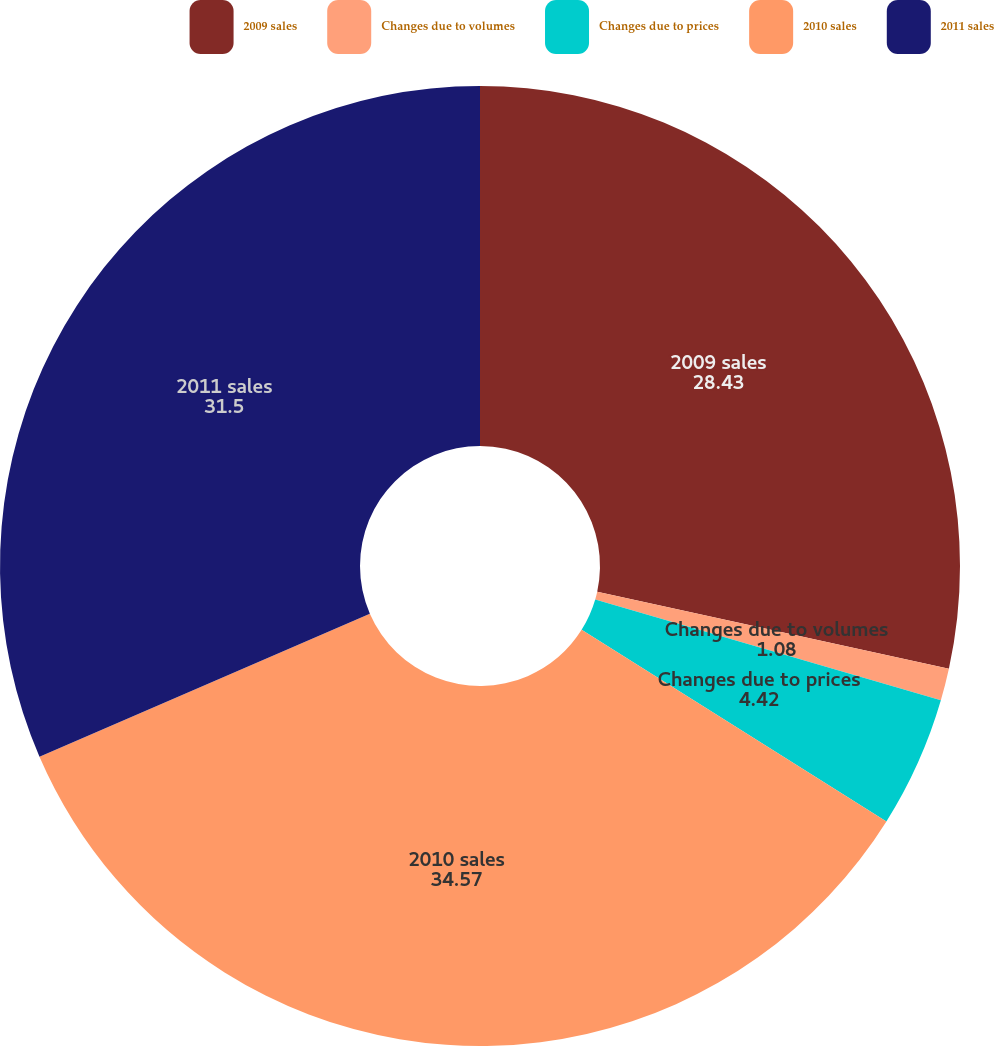<chart> <loc_0><loc_0><loc_500><loc_500><pie_chart><fcel>2009 sales<fcel>Changes due to volumes<fcel>Changes due to prices<fcel>2010 sales<fcel>2011 sales<nl><fcel>28.43%<fcel>1.08%<fcel>4.42%<fcel>34.57%<fcel>31.5%<nl></chart> 